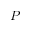<formula> <loc_0><loc_0><loc_500><loc_500>P</formula> 